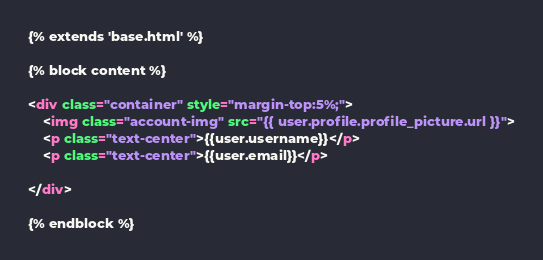Convert code to text. <code><loc_0><loc_0><loc_500><loc_500><_HTML_>{% extends 'base.html' %}

{% block content %}

<div class="container" style="margin-top:5%;">
    <img class="account-img" src="{{ user.profile.profile_picture.url }}">
    <p class="text-center">{{user.username}}</p>
    <p class="text-center">{{user.email}}</p>

</div>

{% endblock %}</code> 